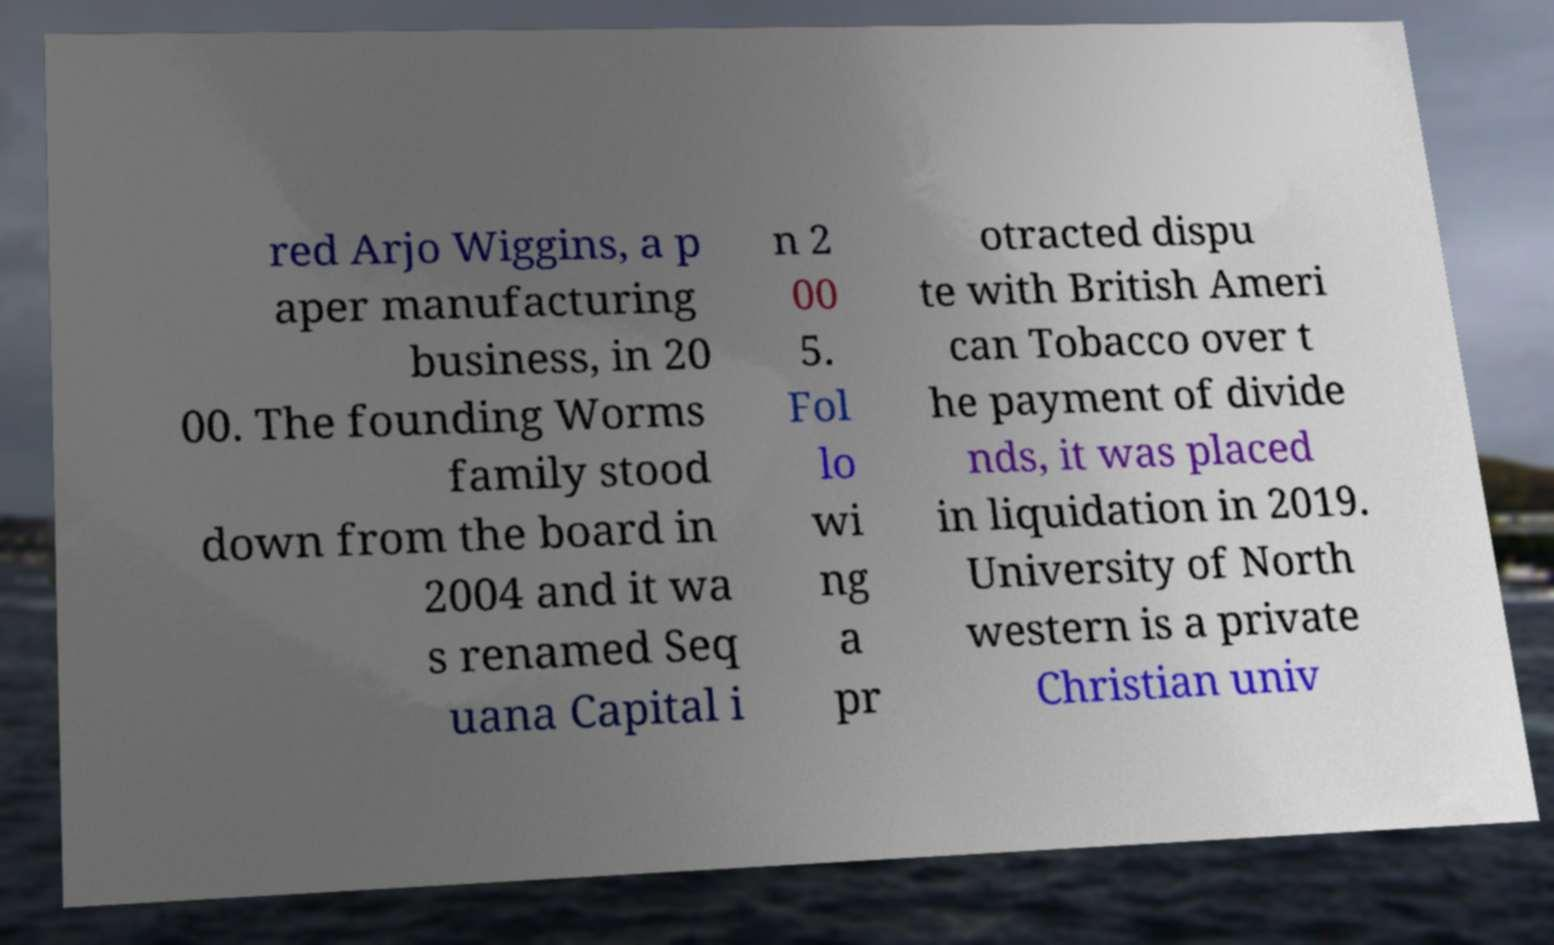For documentation purposes, I need the text within this image transcribed. Could you provide that? red Arjo Wiggins, a p aper manufacturing business, in 20 00. The founding Worms family stood down from the board in 2004 and it wa s renamed Seq uana Capital i n 2 00 5. Fol lo wi ng a pr otracted dispu te with British Ameri can Tobacco over t he payment of divide nds, it was placed in liquidation in 2019. University of North western is a private Christian univ 